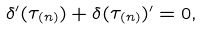Convert formula to latex. <formula><loc_0><loc_0><loc_500><loc_500>\delta ^ { \prime } ( \tau _ { ( n ) } ) + \delta ( \tau _ { ( n ) } ) ^ { \prime } = 0 ,</formula> 